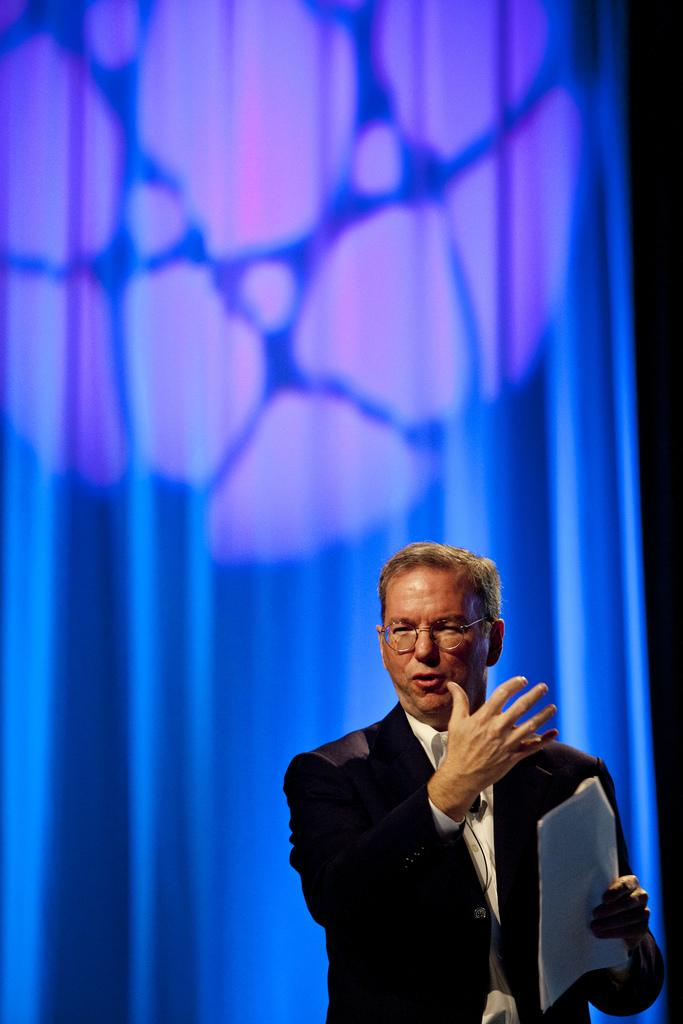What is the main subject of the image? There is a person in the image. What is the person holding in the image? The person is holding a paper. What color is the background of the image? The background of the image is blue. What type of bead is the person wearing on their toes in the image? There is no bead or mention of toes in the image; the person is holding a paper. What is the person using to hammer nails in the image? There is no hammer or nails present in the image; the person is holding a paper. 